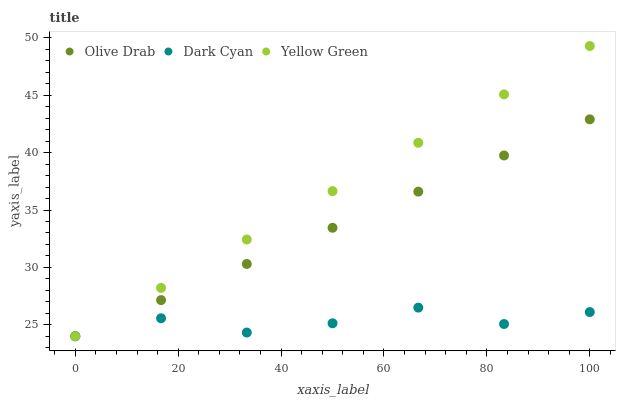Does Dark Cyan have the minimum area under the curve?
Answer yes or no. Yes. Does Yellow Green have the maximum area under the curve?
Answer yes or no. Yes. Does Olive Drab have the minimum area under the curve?
Answer yes or no. No. Does Olive Drab have the maximum area under the curve?
Answer yes or no. No. Is Olive Drab the smoothest?
Answer yes or no. Yes. Is Dark Cyan the roughest?
Answer yes or no. Yes. Is Yellow Green the smoothest?
Answer yes or no. No. Is Yellow Green the roughest?
Answer yes or no. No. Does Dark Cyan have the lowest value?
Answer yes or no. Yes. Does Yellow Green have the highest value?
Answer yes or no. Yes. Does Olive Drab have the highest value?
Answer yes or no. No. Does Dark Cyan intersect Yellow Green?
Answer yes or no. Yes. Is Dark Cyan less than Yellow Green?
Answer yes or no. No. Is Dark Cyan greater than Yellow Green?
Answer yes or no. No. 